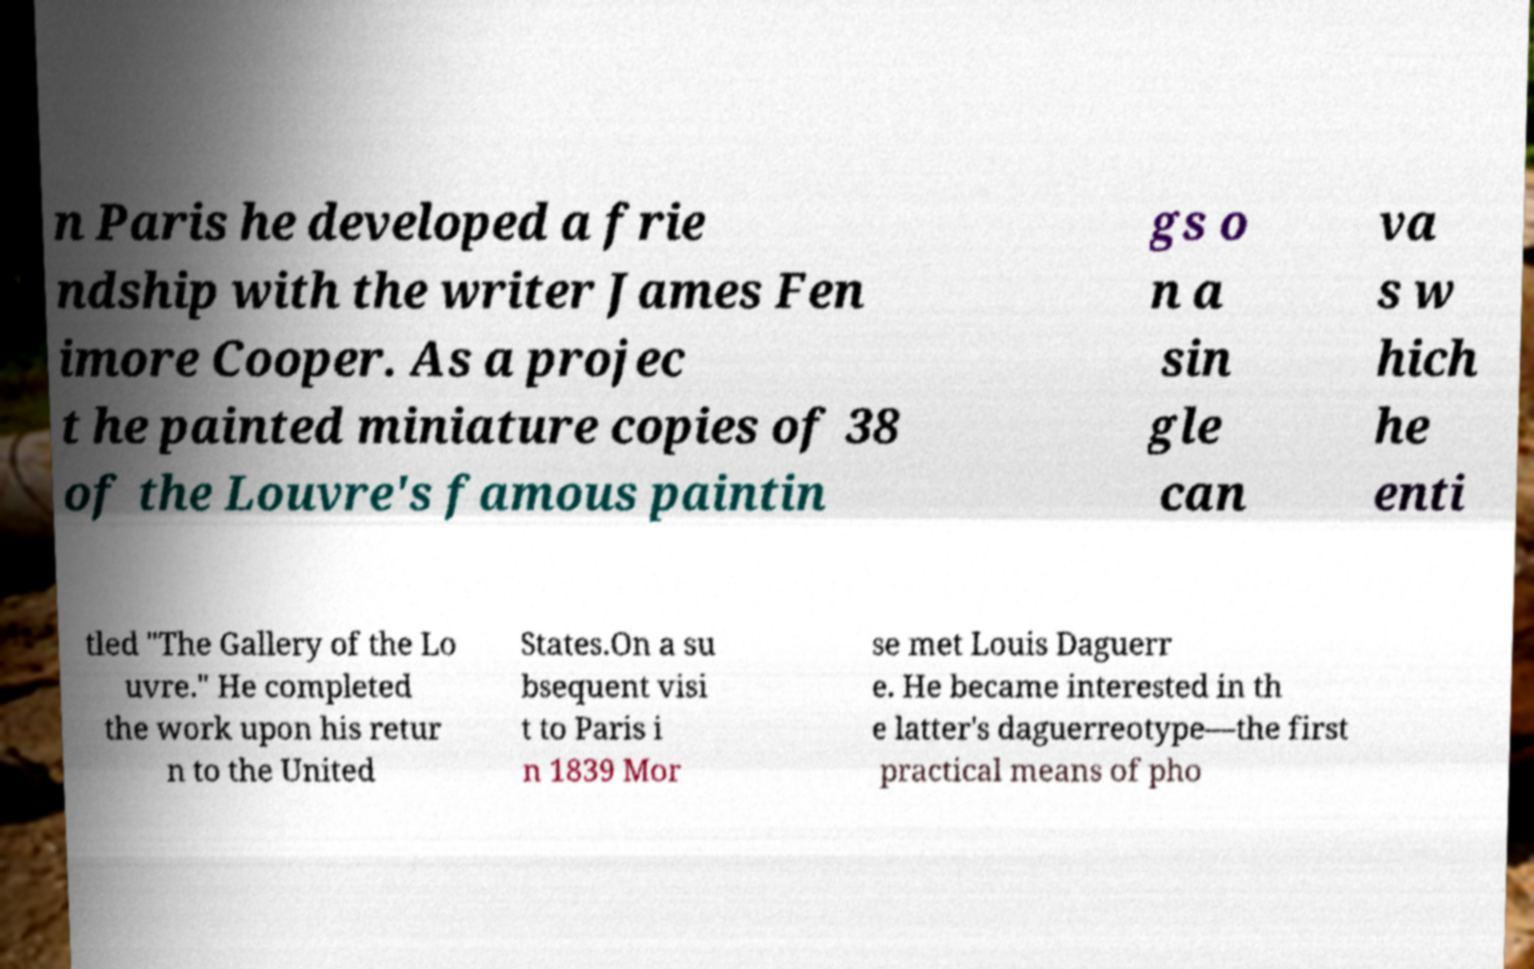What messages or text are displayed in this image? I need them in a readable, typed format. n Paris he developed a frie ndship with the writer James Fen imore Cooper. As a projec t he painted miniature copies of 38 of the Louvre's famous paintin gs o n a sin gle can va s w hich he enti tled "The Gallery of the Lo uvre." He completed the work upon his retur n to the United States.On a su bsequent visi t to Paris i n 1839 Mor se met Louis Daguerr e. He became interested in th e latter's daguerreotype—the first practical means of pho 